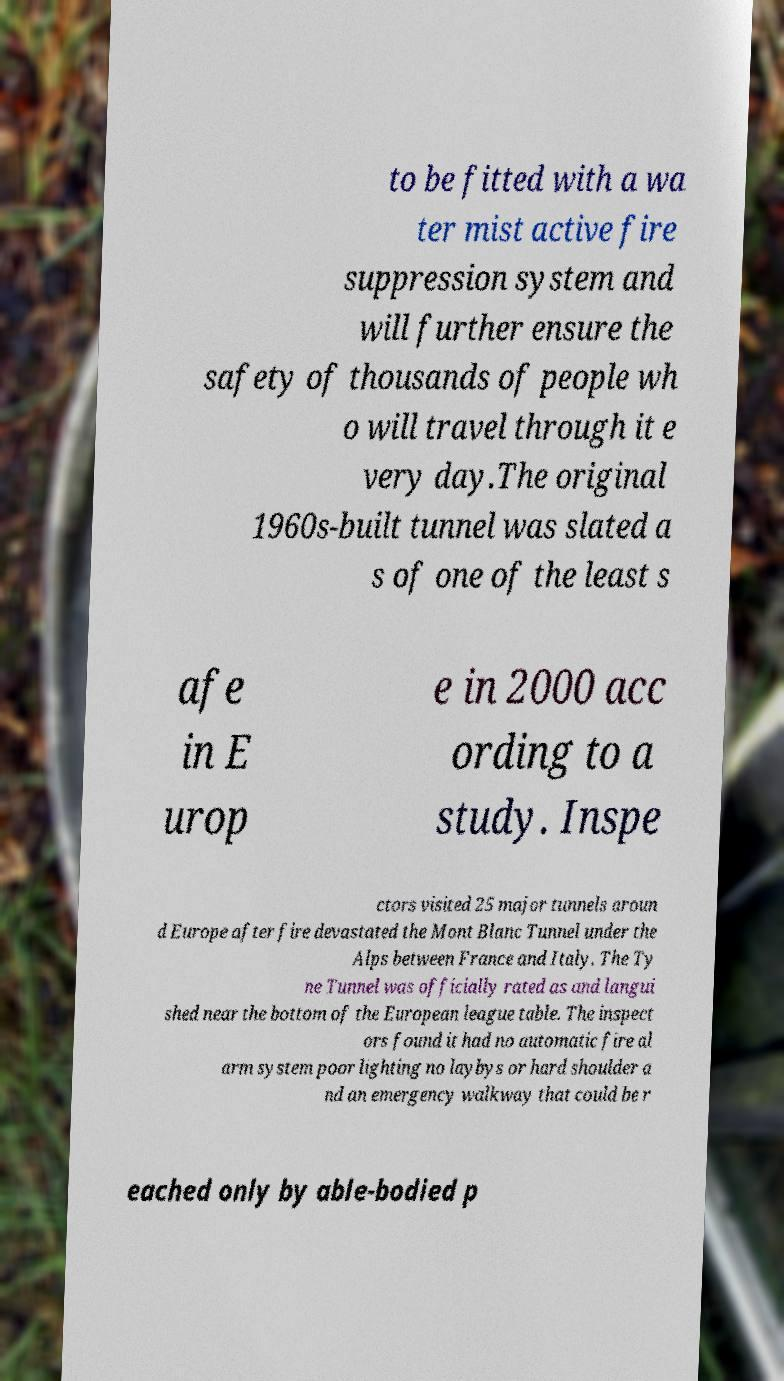Please identify and transcribe the text found in this image. to be fitted with a wa ter mist active fire suppression system and will further ensure the safety of thousands of people wh o will travel through it e very day.The original 1960s-built tunnel was slated a s of one of the least s afe in E urop e in 2000 acc ording to a study. Inspe ctors visited 25 major tunnels aroun d Europe after fire devastated the Mont Blanc Tunnel under the Alps between France and Italy. The Ty ne Tunnel was officially rated as and langui shed near the bottom of the European league table. The inspect ors found it had no automatic fire al arm system poor lighting no laybys or hard shoulder a nd an emergency walkway that could be r eached only by able-bodied p 